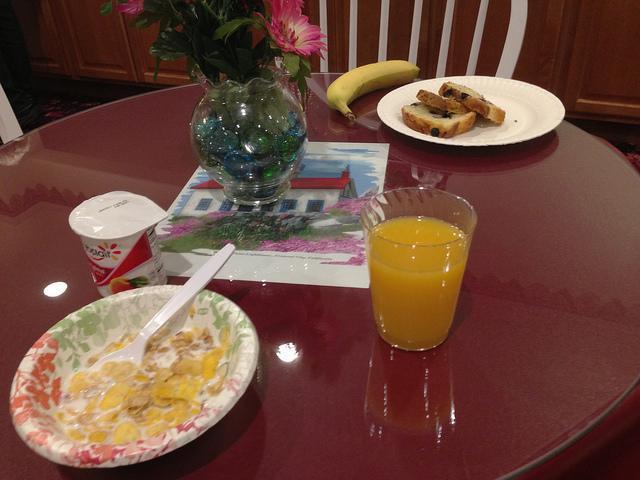What fruit used to prepare items here is darkest?
Make your selection from the four choices given to correctly answer the question.
Options: Apricots, bananas, oranges, blueberries. Blueberries. 